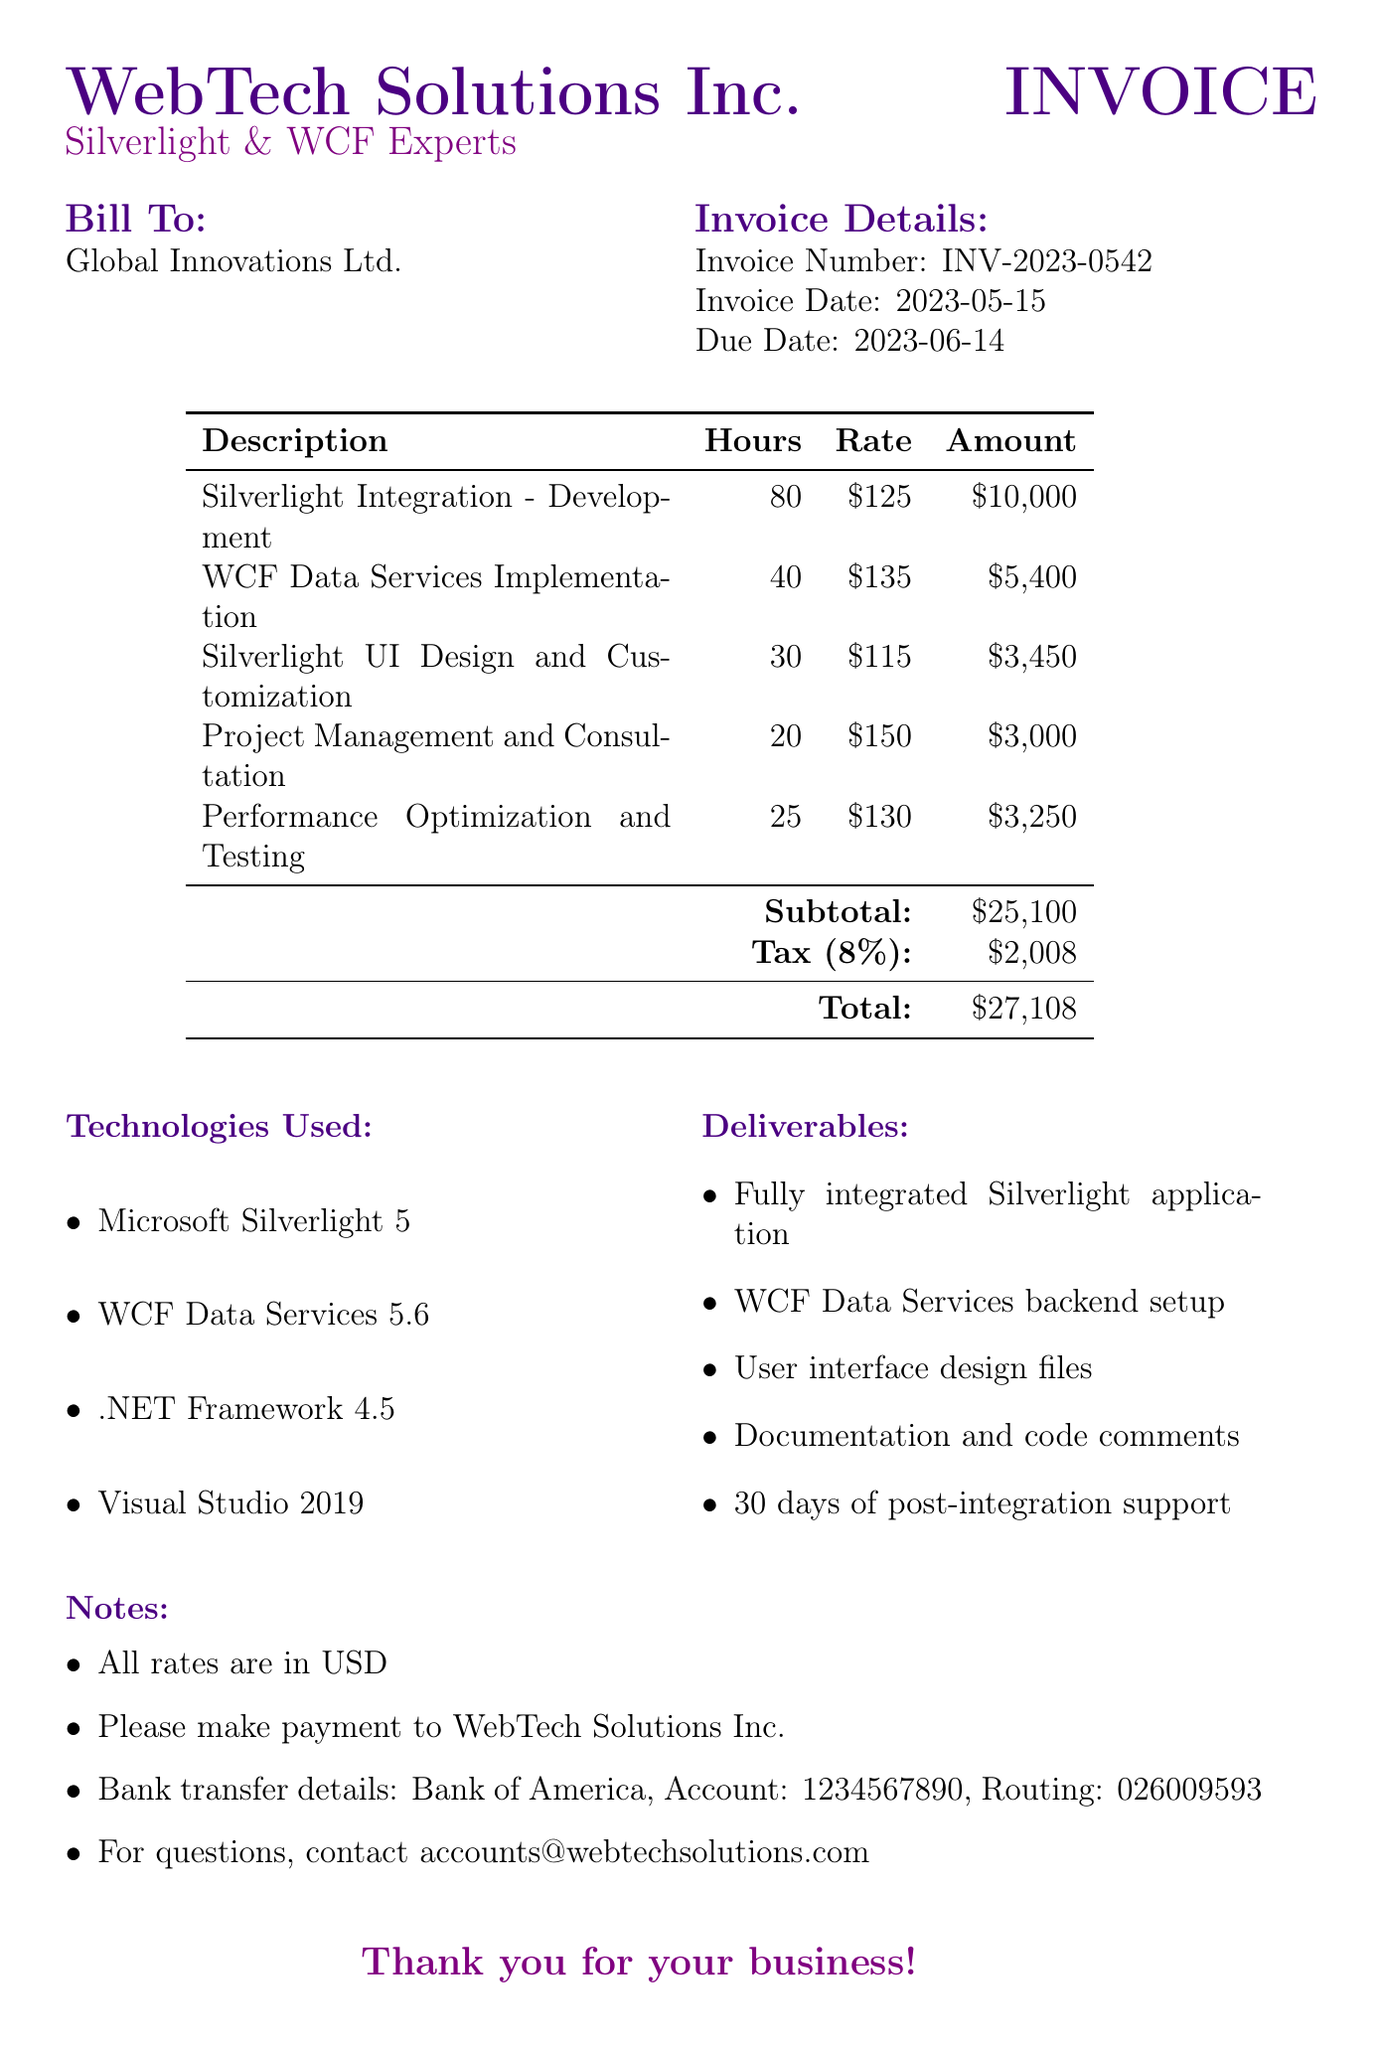what is the invoice number? The invoice number is specified in the document under "Invoice Details."
Answer: INV-2023-0542 what is the total amount due? The total amount is the sum of the subtotal and tax, which is stated in the document.
Answer: 27108 how many hours were billed for Project Management and Consultation? The document details the hours for each service under "services."
Answer: 20 what is the tax rate applied to the invoice? The tax rate is specified in the document.
Answer: 8% what deliverable includes user interface design files? The deliverables section lists various items, and the specific item mentioned is relevant to UI design.
Answer: User interface design files how much is charged per hour for Silverlight Integration - Development? The hourly rate for each service is listed in the document, specifying the charge for this service.
Answer: 125 which technologies were used for this project? The document includes a section that lists the technologies used in the project.
Answer: Microsoft Silverlight 5, WCF Data Services 5.6, .NET Framework 4.5, Visual Studio 2019 when is the payment due date? The due date is specified in the document under "Invoice Details."
Answer: 2023-06-14 